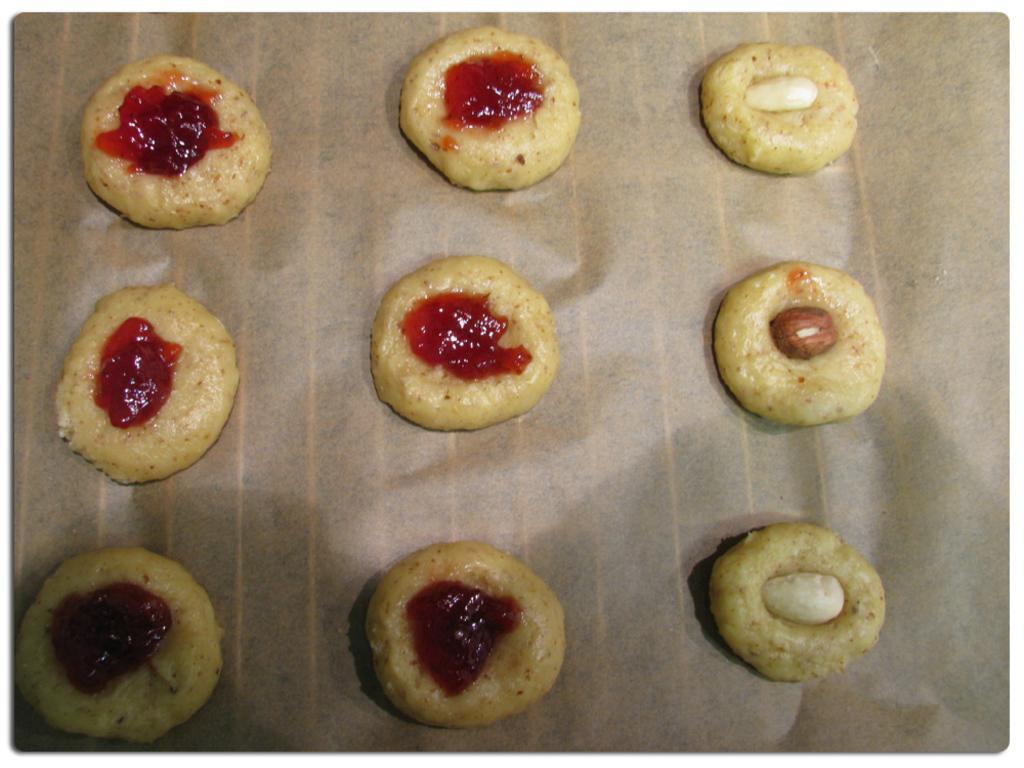In one or two sentences, can you explain what this image depicts? In this image, we can see some food items kept on a paper. 